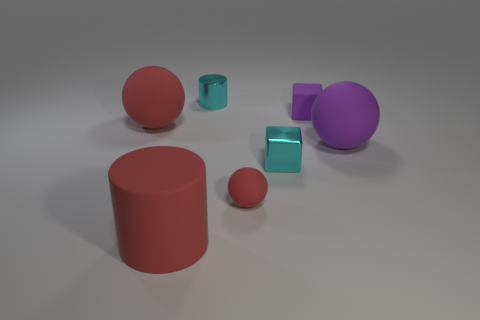Subtract all tiny red rubber spheres. How many spheres are left? 2 Add 1 large gray blocks. How many objects exist? 8 Subtract all purple spheres. How many spheres are left? 2 Subtract 1 cyan blocks. How many objects are left? 6 Subtract all spheres. How many objects are left? 4 Subtract 3 spheres. How many spheres are left? 0 Subtract all brown balls. Subtract all red blocks. How many balls are left? 3 Subtract all blue balls. How many green cylinders are left? 0 Subtract all tiny purple matte blocks. Subtract all tiny purple rubber cubes. How many objects are left? 5 Add 2 blocks. How many blocks are left? 4 